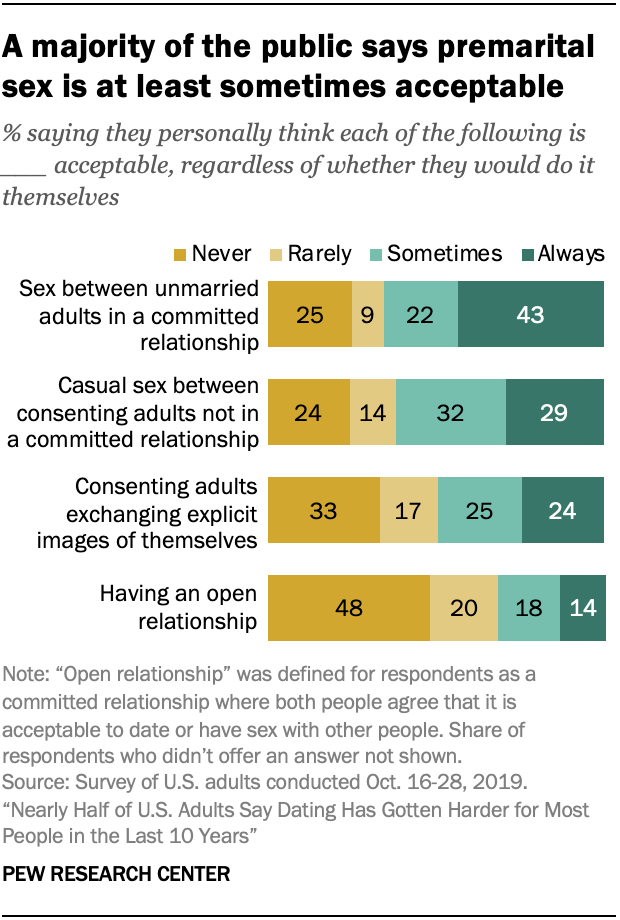Specify some key components in this picture. The value of the leftmost and topmost bar is 25. The product of the median of yellow bars is less than 30. 